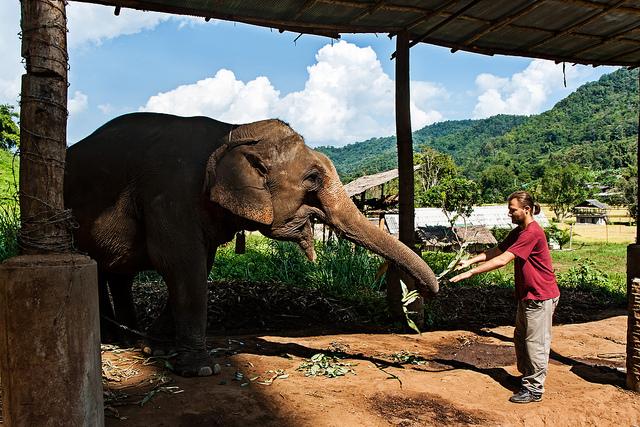Does that look like a secure fence?
Quick response, please. No. What is on the elephants back?
Answer briefly. Nothing. How many elephants are depicted?
Write a very short answer. 1. Is the woman hugging one of the elephants?
Write a very short answer. No. Is the person scared of the animal?
Write a very short answer. No. Is it a sunny day?
Keep it brief. Yes. Is this animal being treated humanely?
Short answer required. Yes. What animal is  the man playing with?
Answer briefly. Elephant. 